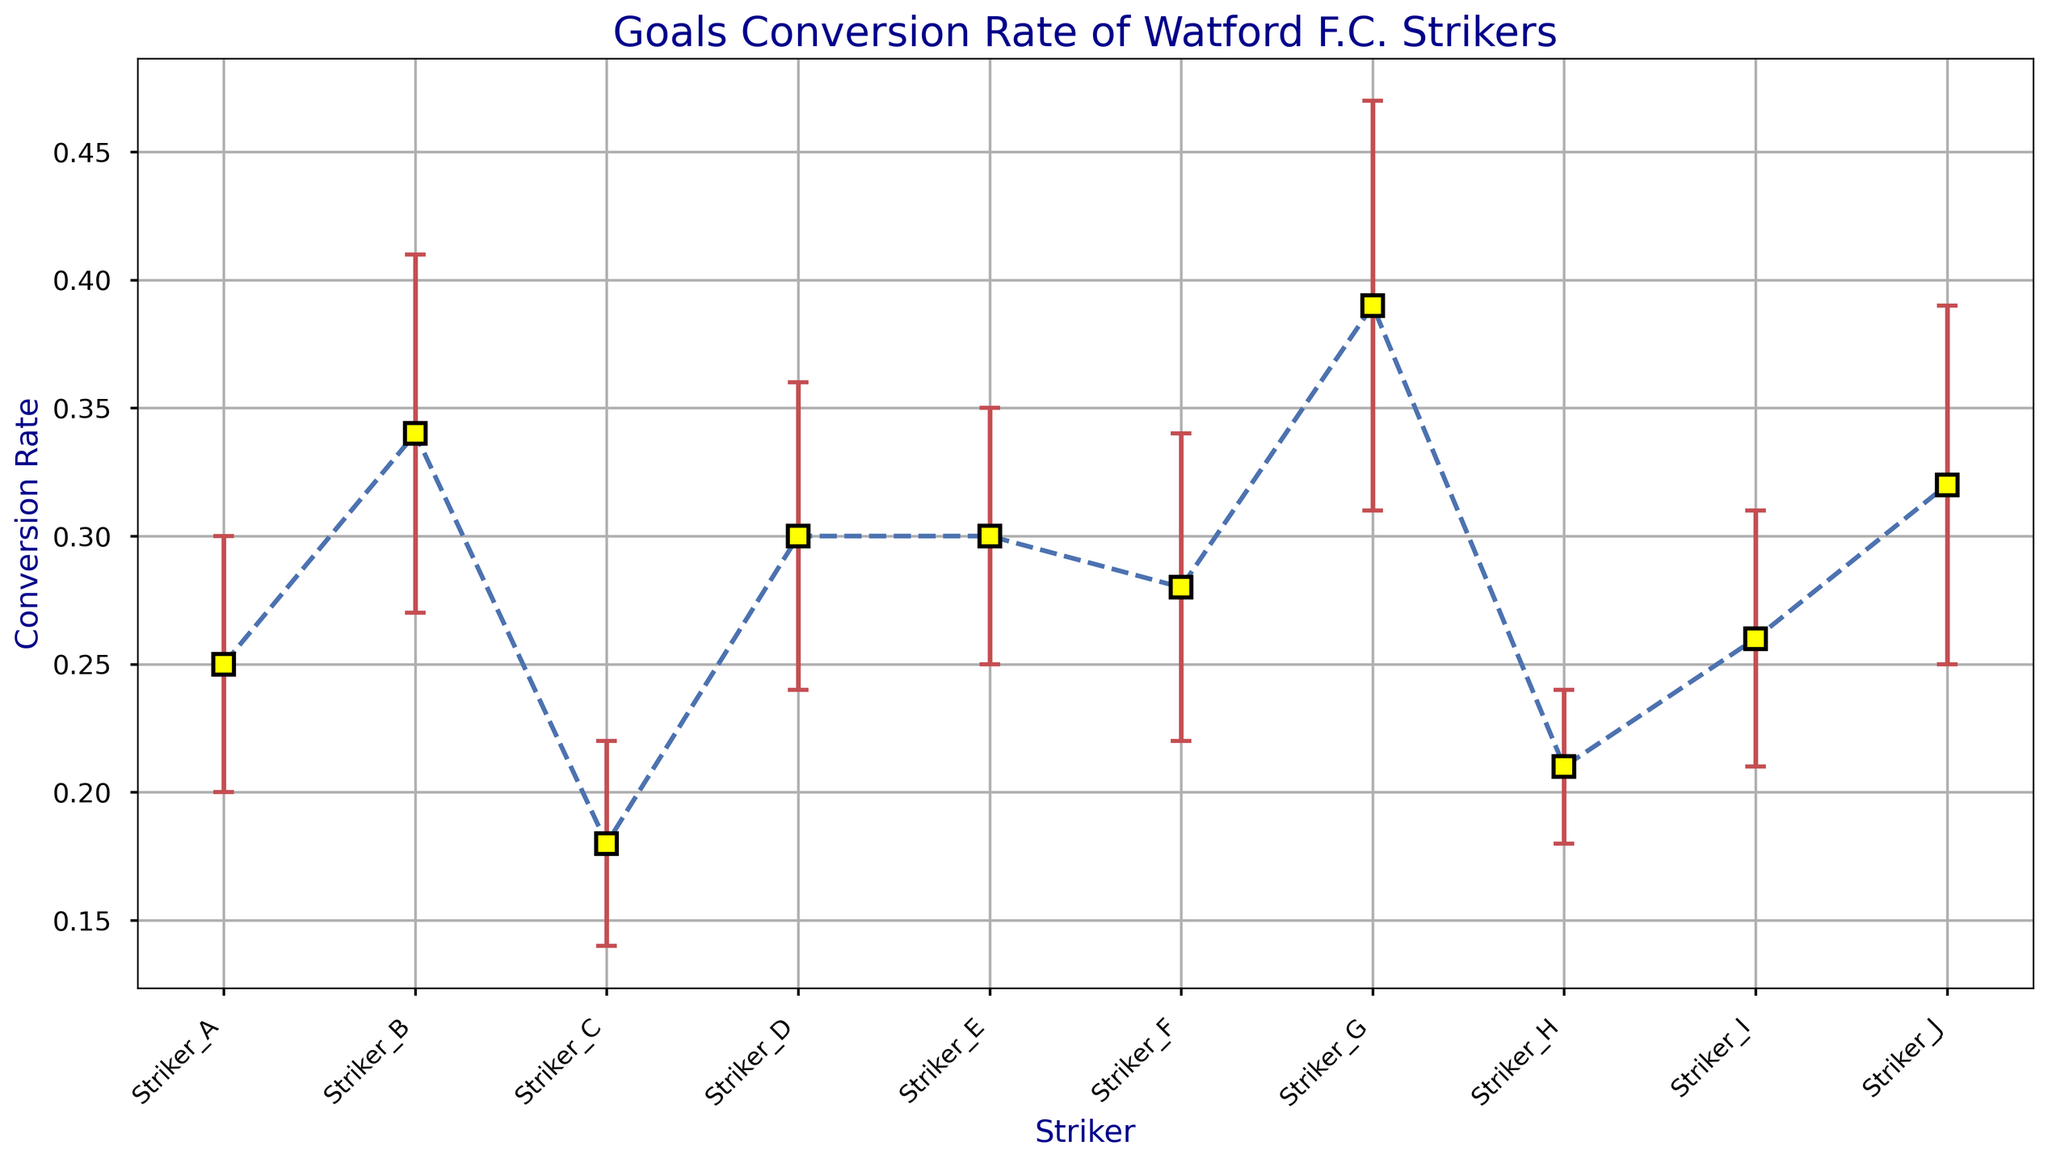Which striker has the highest conversion rate? To find the striker with the highest conversion rate, look for the point that is plotted highest on the y-axis. Striker G is the highest.
Answer: Striker G Which striker has the lowest conversion rate? To find the striker with the lowest conversion rate, look for the point that is plotted lowest on the y-axis. Striker C is the lowest.
Answer: Striker C What is the average conversion rate of all the strikers? Sum the conversion rates of all the strikers and divide by the number of strikers. (0.25 + 0.34 + 0.18 + 0.30 + 0.30 + 0.28 + 0.39 + 0.21 + 0.26 + 0.32) / 10 = 0.283
Answer: 0.283 Which striker has the greatest variability in performance? The striker with the highest standard deviation will have the greatest variability. Look for the largest error bar. Striker G has the highest standard deviation of 0.08.
Answer: Striker G Which striker scored the highest number of goals? The number of goals scored is directly related to the conversion rate and attempts. Striker D scored the highest number of goals (15).
Answer: Striker D Which striker has a conversion rate closest to the average conversion rate? Calculate the average conversion rate (0.283) and compare each striker's rate to this. Striker F has a conversion rate (0.28) closest to the average.
Answer: Striker F What is the difference in conversion rate between the top two strikers in terms of conversion rate? Identify the top two strikers: Striker G (0.39) and Striker B (0.34). Subtract the two conversion rates. 0.39 - 0.34 = 0.05
Answer: 0.05 Which striker has the smallest variability in performance? The striker with the smallest standard deviation will have the least variability. Look for the smallest error bar. Striker H has the lowest standard deviation of 0.03.
Answer: Striker H How many strikers have a conversion rate above 0.30? Identify and count the strikers with a conversion rate higher than 0.30: Striker B, Striker D, Striker E, Striker G, and Striker J.
Answer: 5 